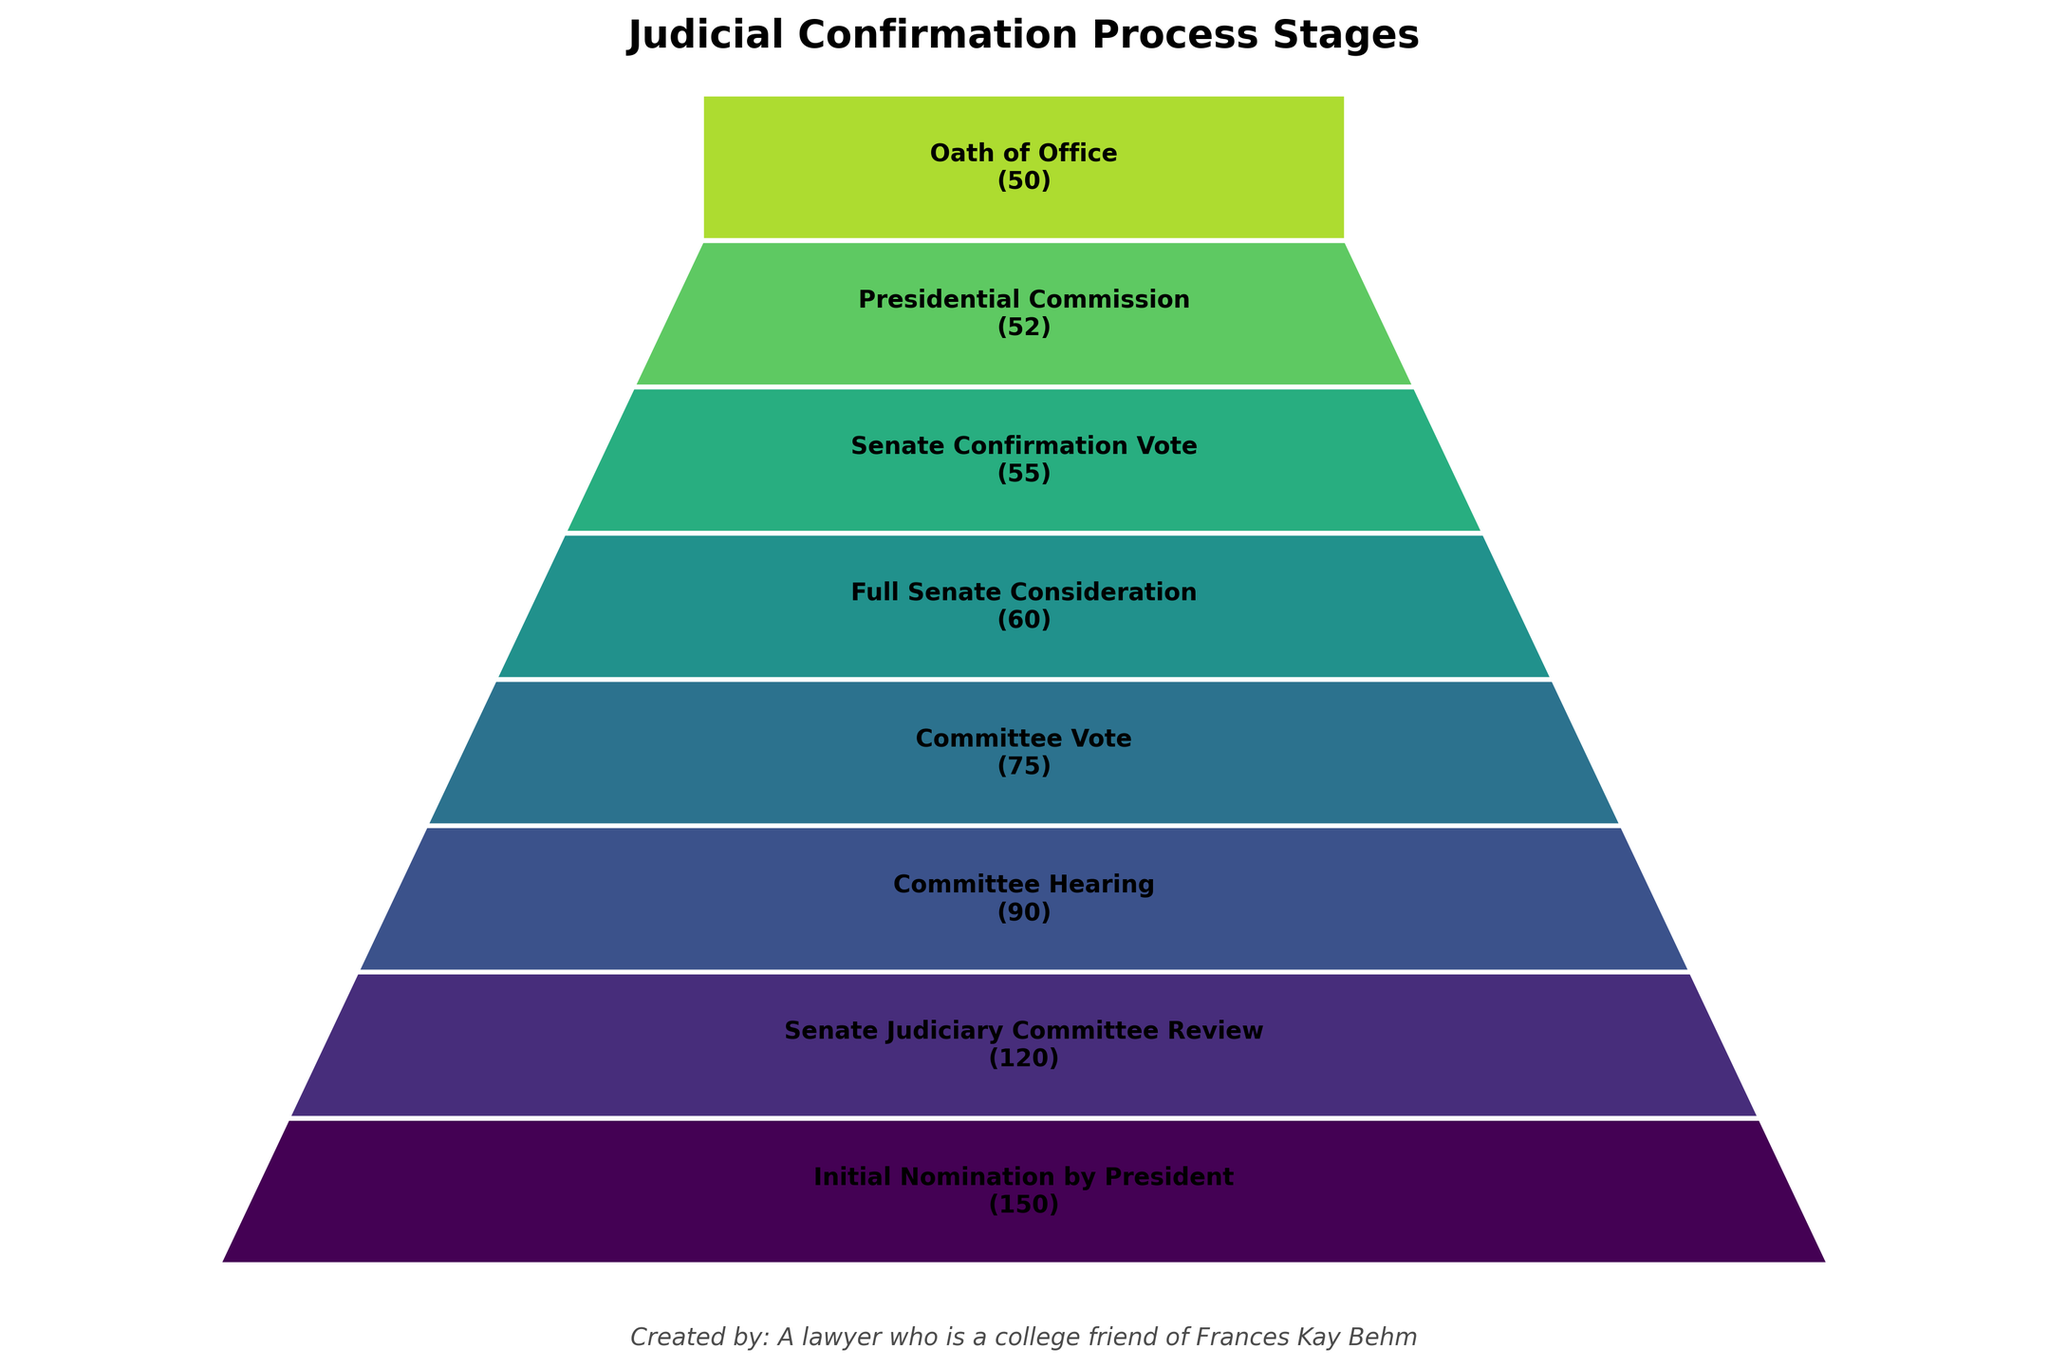How many candidates reached the "Committee Vote" stage? The "Committee Vote" stage lists the number of candidates who reached it directly in the figure. Checking this stage shows that 75 candidates reached the "Committee Vote".
Answer: 75 How many stages are in the judicial confirmation process shown in the chart? The funnel chart visually represents each stage as a separate segment. Counting these segments gives us the total number of stages. There are 8 stages.
Answer: 8 Which stage has the greatest reduction in the number of candidates? To determine the greatest reduction, calculate the difference in the number of candidates between successive stages. The stage with the largest difference is between "Initial Nomination by President" and "Senate Judiciary Committee Review" (150 - 120 = 30).
Answer: Initial Nomination by President to Senate Judiciary Committee Review What's the title of the figure? The title of the figure is usually placed at the top of the chart. For this particular funnel chart, it is noted as "Judicial Confirmation Process Stages".
Answer: Judicial Confirmation Process Stages What is the final number of candidates who took the Oath of Office? The "Oath of Office" stage lists the number of candidates who eventually took the oath. This information is presented directly within that stage on the chart, showing 50.
Answer: 50 How many candidates did not make it past the "Committee Hearing" stage? To calculate this, find the difference between the number of candidates in the "Committee Hearing" stage and the subsequent stage "Committee Vote". 90 - 75 = 15 candidates did not make it past the "Committee Hearing".
Answer: 15 What is the primary color used in the funnel segments? Although we don't have the exact colors, the typical shading used is indicated. The segments are colored using shades from a colormap, here it is noted to use plt.cm.viridis. Therefore, the primary color can be described as various shades of green to blue.
Answer: Shades from green to blue Between which stages is the candidate reduction the smallest? To find the smallest reduction, calculate the differences between the number of candidates for each successive stage and find the smallest value. The smallest reduction is between "Senate Confirmation Vote" and "Presidential Commission" (55 - 52 = 3).
Answer: Senate Confirmation Vote to Presidential Commission How many fewer candidates were there after the "Full Senate Consideration" stage compared to the "Initial Nomination by President"? Subtract the number of candidates at the "Full Senate Consideration" stage from the "Initial Nomination by President". 150 - 60 = 90 fewer candidates.
Answer: 90 What information is included as the personal touch at the bottom of the chart? At the bottom of the chart, there is a text that reads: "Created by: A lawyer who is a college friend of Frances Kay Behm".
Answer: Created by: A lawyer who is a college friend of Frances Kay Behm 